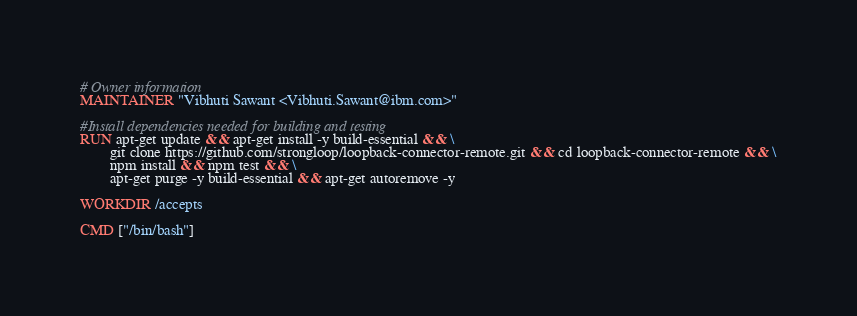Convert code to text. <code><loc_0><loc_0><loc_500><loc_500><_Dockerfile_># Owner information
MAINTAINER "Vibhuti Sawant <Vibhuti.Sawant@ibm.com>"

#Install dependencies needed for building and testing
RUN apt-get update && apt-get install -y build-essential && \
        git clone https://github.com/strongloop/loopback-connector-remote.git && cd loopback-connector-remote && \
        npm install && npm test && \
        apt-get purge -y build-essential && apt-get autoremove -y

WORKDIR /accepts

CMD ["/bin/bash"]
</code> 